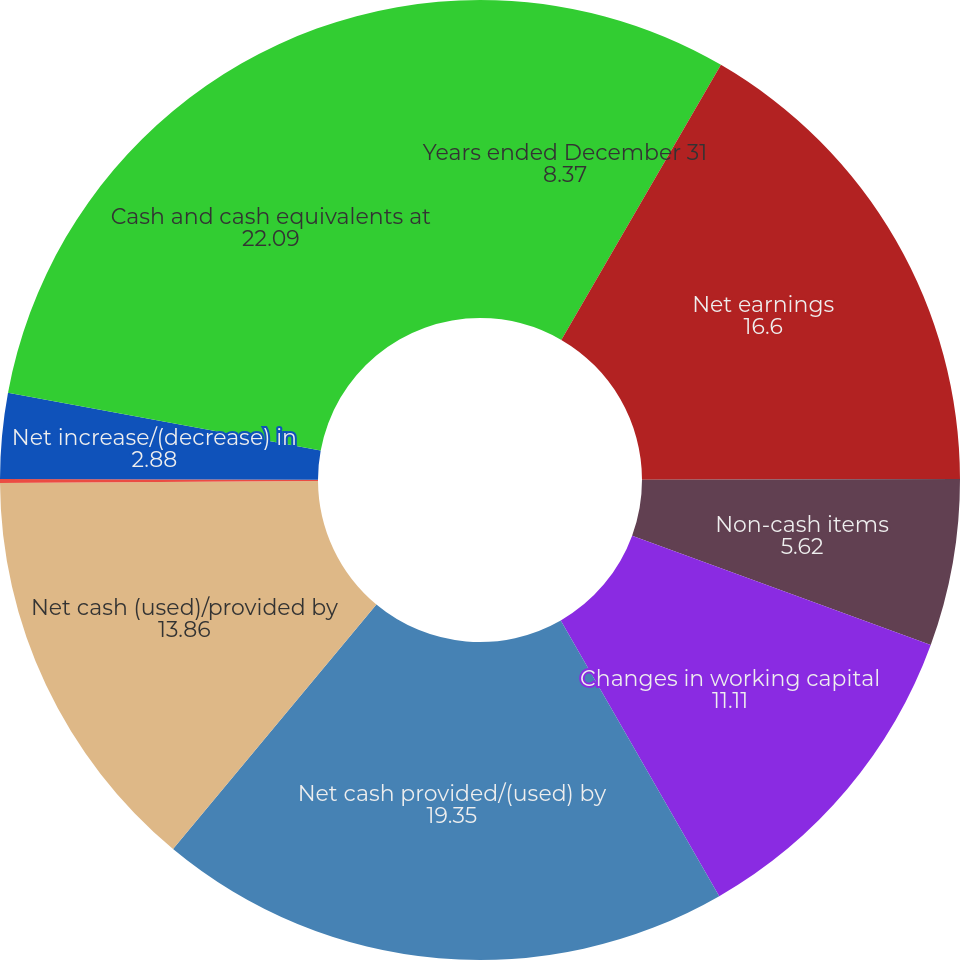<chart> <loc_0><loc_0><loc_500><loc_500><pie_chart><fcel>Years ended December 31<fcel>Net earnings<fcel>Non-cash items<fcel>Changes in working capital<fcel>Net cash provided/(used) by<fcel>Net cash (used)/provided by<fcel>Effect of exchange rate<fcel>Net increase/(decrease) in<fcel>Cash and cash equivalents at<nl><fcel>8.37%<fcel>16.6%<fcel>5.62%<fcel>11.11%<fcel>19.35%<fcel>13.86%<fcel>0.13%<fcel>2.88%<fcel>22.09%<nl></chart> 